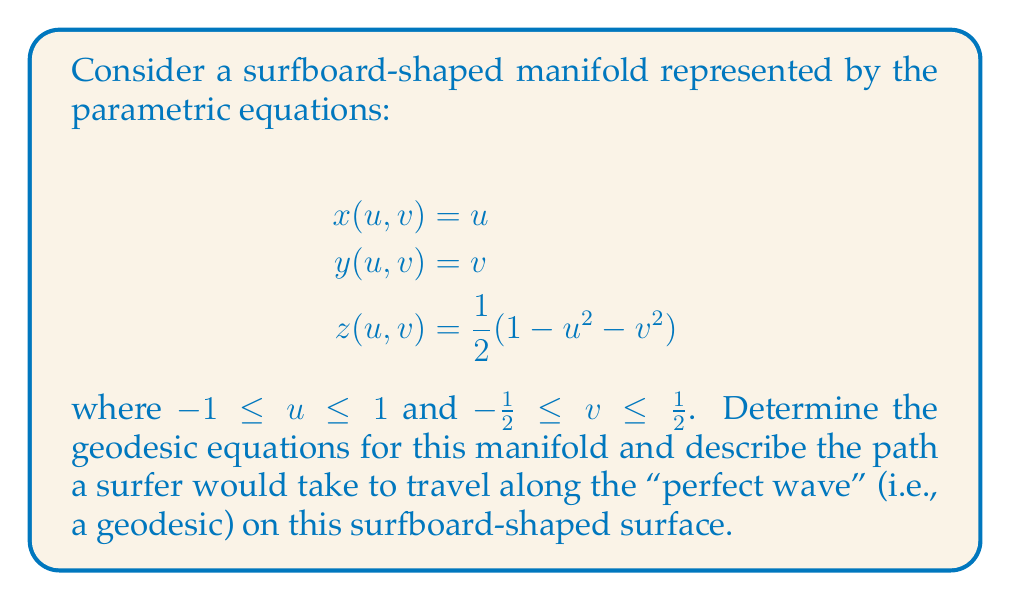Help me with this question. To find the geodesics on this surfboard-shaped manifold, we need to follow these steps:

1. Calculate the metric tensor $g_{ij}$:
   First, we compute the partial derivatives:
   $$\frac{\partial x}{\partial u} = 1, \frac{\partial x}{\partial v} = 0$$
   $$\frac{\partial y}{\partial u} = 0, \frac{\partial y}{\partial v} = 1$$
   $$\frac{\partial z}{\partial u} = -u, \frac{\partial z}{\partial v} = -v$$

   Now we can calculate the metric tensor components:
   $$g_{11} = 1 + u^2$$
   $$g_{12} = g_{21} = uv$$
   $$g_{22} = 1 + v^2$$

2. Calculate the Christoffel symbols $\Gamma^k_{ij}$:
   Using the formula:
   $$\Gamma^k_{ij} = \frac{1}{2}g^{kl}(\frac{\partial g_{il}}{\partial x^j} + \frac{\partial g_{jl}}{\partial x^i} - \frac{\partial g_{ij}}{\partial x^l})$$

   We get:
   $$\Gamma^1_{11} = \frac{u}{1+u^2+v^2}, \Gamma^1_{12} = \frac{v}{1+u^2+v^2}$$
   $$\Gamma^1_{22} = -\frac{u(1+v^2)}{1+u^2+v^2}$$
   $$\Gamma^2_{11} = -\frac{v(1+u^2)}{1+u^2+v^2}, \Gamma^2_{12} = \frac{u}{1+u^2+v^2}$$
   $$\Gamma^2_{22} = \frac{v}{1+u^2+v^2}$$

3. Write the geodesic equations:
   Using the general form of geodesic equations:
   $$\frac{d^2x^k}{dt^2} + \Gamma^k_{ij}\frac{dx^i}{dt}\frac{dx^j}{dt} = 0$$

   We get two coupled differential equations:
   $$\frac{d^2u}{dt^2} + \frac{u}{1+u^2+v^2}(\frac{du}{dt})^2 + \frac{2v}{1+u^2+v^2}\frac{du}{dt}\frac{dv}{dt} - \frac{u(1+v^2)}{1+u^2+v^2}(\frac{dv}{dt})^2 = 0$$
   $$\frac{d^2v}{dt^2} - \frac{v(1+u^2)}{1+u^2+v^2}(\frac{du}{dt})^2 + \frac{2u}{1+u^2+v^2}\frac{du}{dt}\frac{dv}{dt} + \frac{v}{1+u^2+v^2}(\frac{dv}{dt})^2 = 0$$

4. Interpret the results:
   These equations describe the path a surfer would take to travel along the "perfect wave" on this surfboard-shaped surface. The geodesics are curves that locally minimize the distance between two points on the manifold.

   To visualize this, imagine a surfer trying to take the most efficient path along the surface of the board. The curvature of the board affects the surfer's trajectory, causing them to follow a curved path that may not be a straight line when viewed from above.

   The exact path would depend on the initial position and velocity of the surfer, which would serve as initial conditions for solving these differential equations numerically.
Answer: The geodesic equations for the surfboard-shaped manifold are:

$$\frac{d^2u}{dt^2} + \frac{u}{1+u^2+v^2}(\frac{du}{dt})^2 + \frac{2v}{1+u^2+v^2}\frac{du}{dt}\frac{dv}{dt} - \frac{u(1+v^2)}{1+u^2+v^2}(\frac{dv}{dt})^2 = 0$$
$$\frac{d^2v}{dt^2} - \frac{v(1+u^2)}{1+u^2+v^2}(\frac{du}{dt})^2 + \frac{2u}{1+u^2+v^2}\frac{du}{dt}\frac{dv}{dt} + \frac{v}{1+u^2+v^2}(\frac{dv}{dt})^2 = 0$$ 